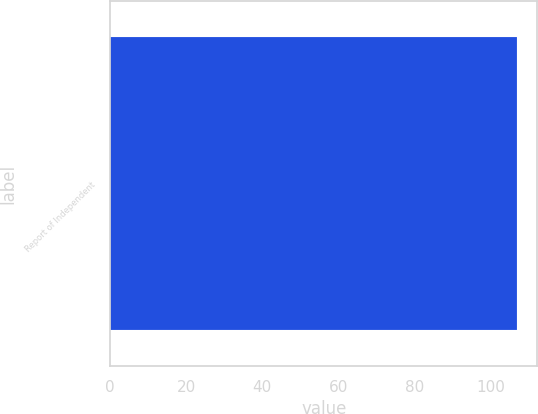<chart> <loc_0><loc_0><loc_500><loc_500><bar_chart><fcel>Report of Independent<nl><fcel>107<nl></chart> 